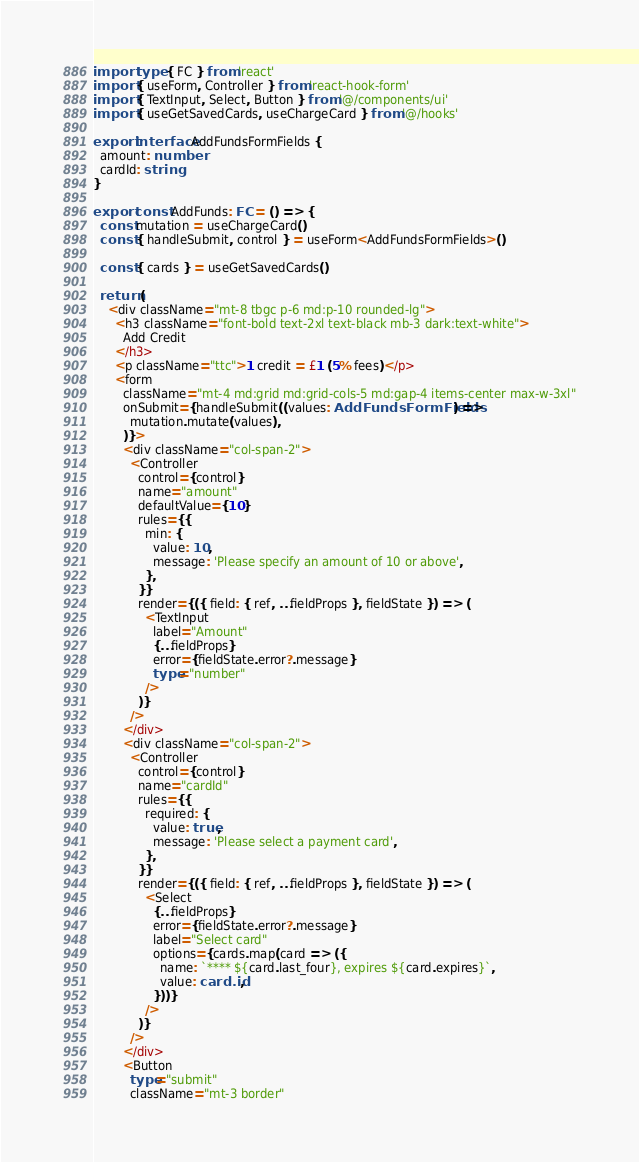<code> <loc_0><loc_0><loc_500><loc_500><_TypeScript_>import type { FC } from 'react'
import { useForm, Controller } from 'react-hook-form'
import { TextInput, Select, Button } from '@/components/ui'
import { useGetSavedCards, useChargeCard } from '@/hooks'

export interface AddFundsFormFields {
  amount: number
  cardId: string
}

export const AddFunds: FC = () => {
  const mutation = useChargeCard()
  const { handleSubmit, control } = useForm<AddFundsFormFields>()

  const { cards } = useGetSavedCards()

  return (
    <div className="mt-8 tbgc p-6 md:p-10 rounded-lg">
      <h3 className="font-bold text-2xl text-black mb-3 dark:text-white">
        Add Credit
      </h3>
      <p className="ttc">1 credit = £1 (5% fees)</p>
      <form
        className="mt-4 md:grid md:grid-cols-5 md:gap-4 items-center max-w-3xl"
        onSubmit={handleSubmit((values: AddFundsFormFields) =>
          mutation.mutate(values),
        )}>
        <div className="col-span-2">
          <Controller
            control={control}
            name="amount"
            defaultValue={10}
            rules={{
              min: {
                value: 10,
                message: 'Please specify an amount of 10 or above',
              },
            }}
            render={({ field: { ref, ...fieldProps }, fieldState }) => (
              <TextInput
                label="Amount"
                {...fieldProps}
                error={fieldState.error?.message}
                type="number"
              />
            )}
          />
        </div>
        <div className="col-span-2">
          <Controller
            control={control}
            name="cardId"
            rules={{
              required: {
                value: true,
                message: 'Please select a payment card',
              },
            }}
            render={({ field: { ref, ...fieldProps }, fieldState }) => (
              <Select
                {...fieldProps}
                error={fieldState.error?.message}
                label="Select card"
                options={cards.map(card => ({
                  name: `**** ${card.last_four}, expires ${card.expires}`,
                  value: card.id,
                }))}
              />
            )}
          />
        </div>
        <Button
          type="submit"
          className="mt-3 border"</code> 